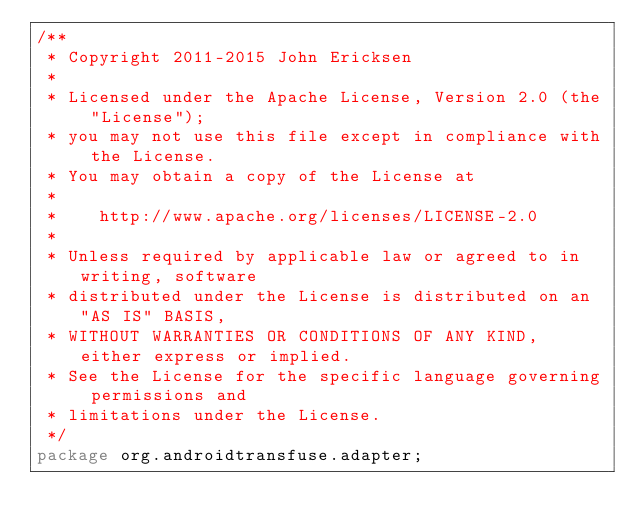<code> <loc_0><loc_0><loc_500><loc_500><_Java_>/**
 * Copyright 2011-2015 John Ericksen
 *
 * Licensed under the Apache License, Version 2.0 (the "License");
 * you may not use this file except in compliance with the License.
 * You may obtain a copy of the License at
 *
 *    http://www.apache.org/licenses/LICENSE-2.0
 *
 * Unless required by applicable law or agreed to in writing, software
 * distributed under the License is distributed on an "AS IS" BASIS,
 * WITHOUT WARRANTIES OR CONDITIONS OF ANY KIND, either express or implied.
 * See the License for the specific language governing permissions and
 * limitations under the License.
 */
package org.androidtransfuse.adapter;
</code> 